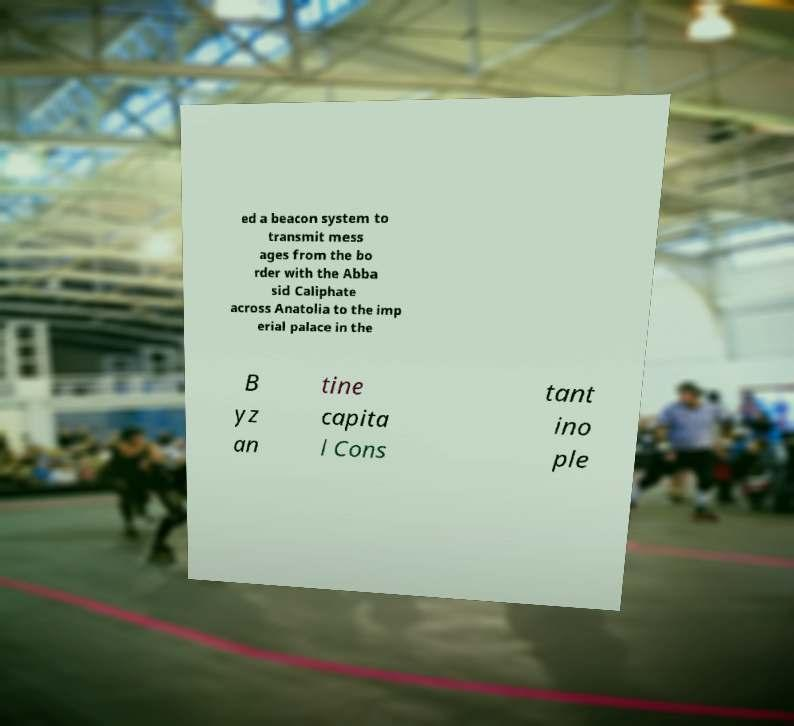Can you read and provide the text displayed in the image?This photo seems to have some interesting text. Can you extract and type it out for me? ed a beacon system to transmit mess ages from the bo rder with the Abba sid Caliphate across Anatolia to the imp erial palace in the B yz an tine capita l Cons tant ino ple 